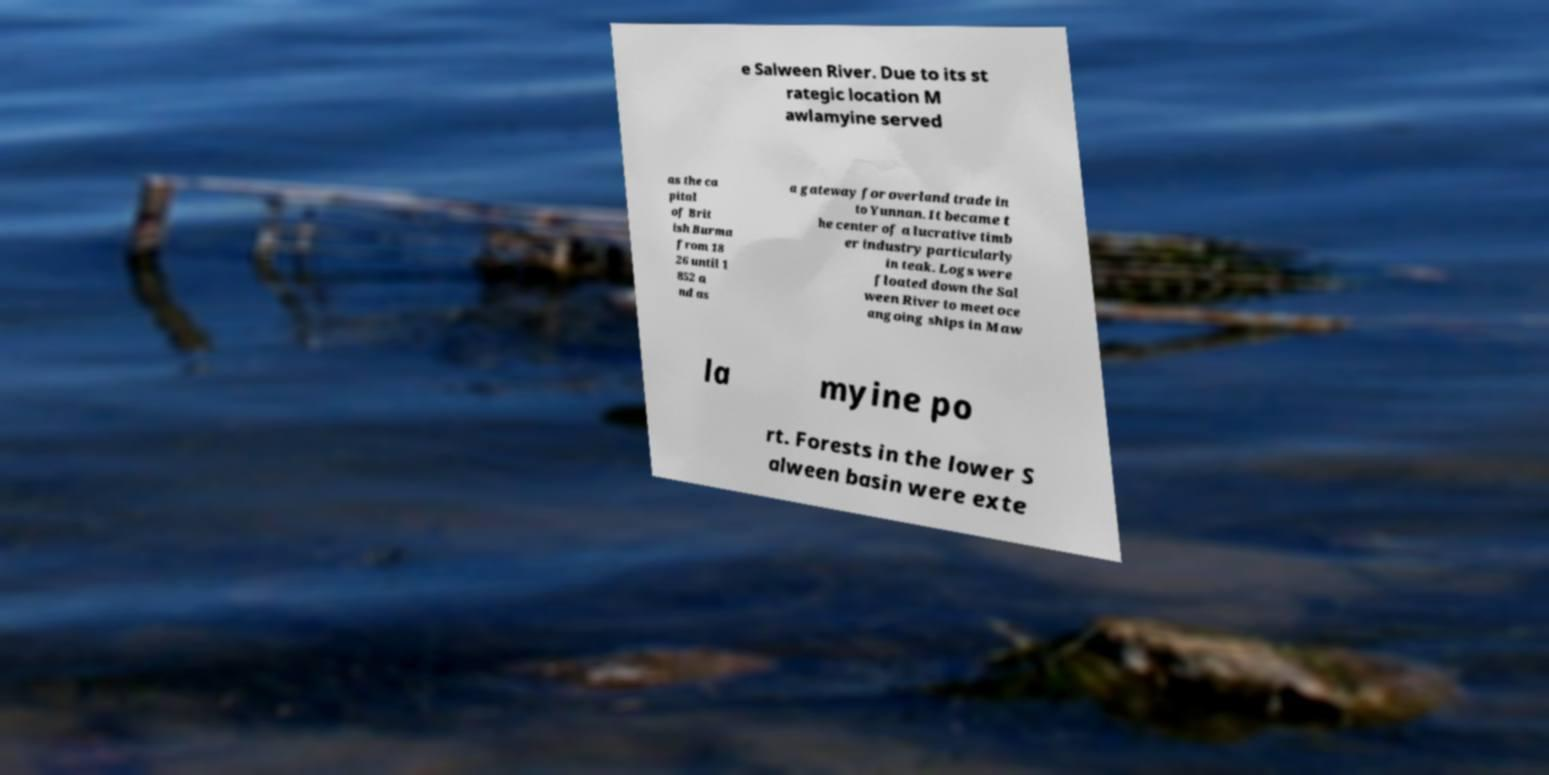What messages or text are displayed in this image? I need them in a readable, typed format. e Salween River. Due to its st rategic location M awlamyine served as the ca pital of Brit ish Burma from 18 26 until 1 852 a nd as a gateway for overland trade in to Yunnan. It became t he center of a lucrative timb er industry particularly in teak. Logs were floated down the Sal ween River to meet oce angoing ships in Maw la myine po rt. Forests in the lower S alween basin were exte 